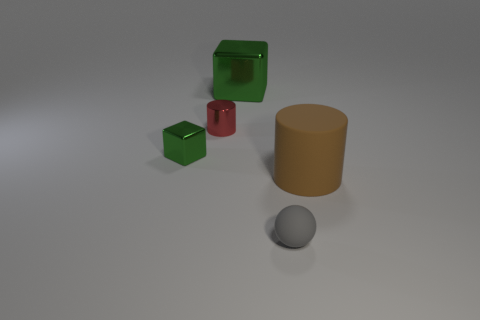What material is the big brown thing that is the same shape as the red object?
Your answer should be compact. Rubber. What is the color of the small thing that is both in front of the small red metal object and behind the tiny gray ball?
Ensure brevity in your answer.  Green. The red object is what size?
Offer a terse response. Small. Do the small object to the right of the large green object and the small cylinder have the same color?
Provide a succinct answer. No. Is the number of green metal cubes that are right of the tiny red metallic thing greater than the number of metallic cylinders right of the large brown cylinder?
Keep it short and to the point. Yes. Are there more rubber things than tiny brown metal cubes?
Offer a very short reply. Yes. There is a thing that is left of the tiny ball and in front of the red thing; what is its size?
Give a very brief answer. Small. What is the shape of the big brown rubber thing?
Keep it short and to the point. Cylinder. Is the number of blocks on the right side of the gray matte ball greater than the number of blue rubber cubes?
Your response must be concise. No. What shape is the big object in front of the thing behind the cylinder that is behind the brown rubber cylinder?
Offer a very short reply. Cylinder. 